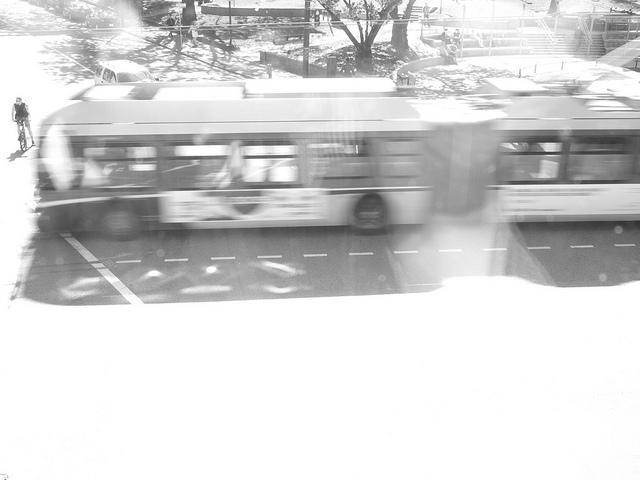How many people are seen?
Give a very brief answer. 1. How many buses are visible?
Give a very brief answer. 2. 